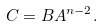<formula> <loc_0><loc_0><loc_500><loc_500>C = B A ^ { n - 2 } .</formula> 